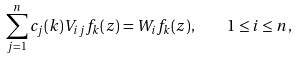Convert formula to latex. <formula><loc_0><loc_0><loc_500><loc_500>\sum _ { j = 1 } ^ { n } c _ { j } ( k ) V _ { i j } f _ { k } ( z ) = W _ { i } f _ { k } ( z ) , \quad 1 \leq i \leq n ,</formula> 